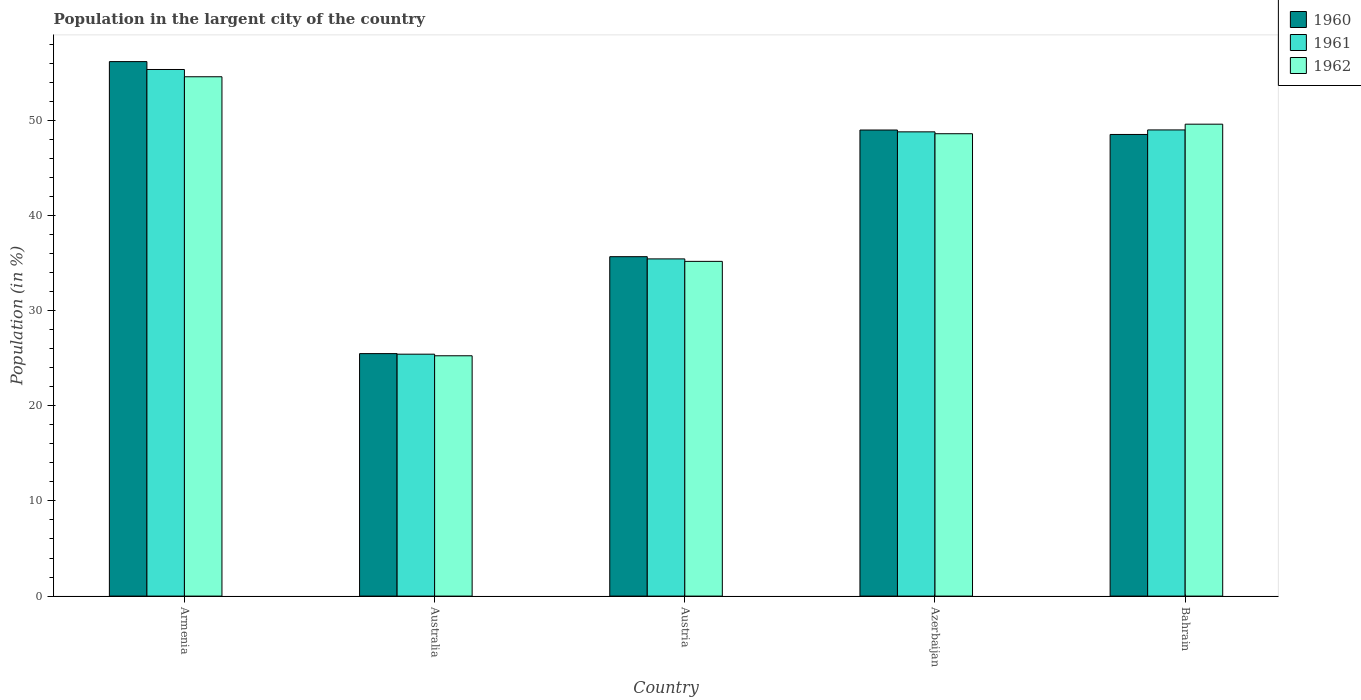How many groups of bars are there?
Provide a short and direct response. 5. Are the number of bars on each tick of the X-axis equal?
Offer a very short reply. Yes. What is the percentage of population in the largent city in 1960 in Armenia?
Ensure brevity in your answer.  56.16. Across all countries, what is the maximum percentage of population in the largent city in 1960?
Give a very brief answer. 56.16. Across all countries, what is the minimum percentage of population in the largent city in 1962?
Provide a short and direct response. 25.25. In which country was the percentage of population in the largent city in 1961 maximum?
Your answer should be compact. Armenia. What is the total percentage of population in the largent city in 1961 in the graph?
Provide a short and direct response. 213.95. What is the difference between the percentage of population in the largent city in 1961 in Armenia and that in Bahrain?
Provide a succinct answer. 6.35. What is the difference between the percentage of population in the largent city in 1961 in Austria and the percentage of population in the largent city in 1960 in Azerbaijan?
Provide a succinct answer. -13.54. What is the average percentage of population in the largent city in 1961 per country?
Offer a very short reply. 42.79. What is the difference between the percentage of population in the largent city of/in 1960 and percentage of population in the largent city of/in 1962 in Austria?
Ensure brevity in your answer.  0.49. In how many countries, is the percentage of population in the largent city in 1960 greater than 54 %?
Your answer should be very brief. 1. What is the ratio of the percentage of population in the largent city in 1960 in Armenia to that in Azerbaijan?
Provide a short and direct response. 1.15. Is the percentage of population in the largent city in 1962 in Australia less than that in Austria?
Provide a succinct answer. Yes. What is the difference between the highest and the second highest percentage of population in the largent city in 1962?
Make the answer very short. -1. What is the difference between the highest and the lowest percentage of population in the largent city in 1960?
Your response must be concise. 30.68. In how many countries, is the percentage of population in the largent city in 1962 greater than the average percentage of population in the largent city in 1962 taken over all countries?
Your response must be concise. 3. What does the 3rd bar from the left in Bahrain represents?
Make the answer very short. 1962. What does the 2nd bar from the right in Armenia represents?
Offer a very short reply. 1961. How many bars are there?
Provide a succinct answer. 15. Are all the bars in the graph horizontal?
Provide a short and direct response. No. Does the graph contain grids?
Offer a terse response. No. How many legend labels are there?
Make the answer very short. 3. How are the legend labels stacked?
Make the answer very short. Vertical. What is the title of the graph?
Keep it short and to the point. Population in the largent city of the country. Does "2002" appear as one of the legend labels in the graph?
Ensure brevity in your answer.  No. What is the label or title of the X-axis?
Offer a very short reply. Country. What is the Population (in %) in 1960 in Armenia?
Offer a terse response. 56.16. What is the Population (in %) of 1961 in Armenia?
Your answer should be very brief. 55.33. What is the Population (in %) of 1962 in Armenia?
Keep it short and to the point. 54.57. What is the Population (in %) in 1960 in Australia?
Your response must be concise. 25.48. What is the Population (in %) of 1961 in Australia?
Offer a terse response. 25.42. What is the Population (in %) in 1962 in Australia?
Your response must be concise. 25.25. What is the Population (in %) of 1960 in Austria?
Your response must be concise. 35.66. What is the Population (in %) in 1961 in Austria?
Keep it short and to the point. 35.43. What is the Population (in %) of 1962 in Austria?
Make the answer very short. 35.17. What is the Population (in %) of 1960 in Azerbaijan?
Ensure brevity in your answer.  48.97. What is the Population (in %) of 1961 in Azerbaijan?
Provide a succinct answer. 48.78. What is the Population (in %) of 1962 in Azerbaijan?
Your answer should be very brief. 48.58. What is the Population (in %) in 1960 in Bahrain?
Give a very brief answer. 48.51. What is the Population (in %) of 1961 in Bahrain?
Offer a terse response. 48.98. What is the Population (in %) in 1962 in Bahrain?
Provide a succinct answer. 49.59. Across all countries, what is the maximum Population (in %) of 1960?
Provide a succinct answer. 56.16. Across all countries, what is the maximum Population (in %) in 1961?
Give a very brief answer. 55.33. Across all countries, what is the maximum Population (in %) in 1962?
Make the answer very short. 54.57. Across all countries, what is the minimum Population (in %) of 1960?
Your answer should be very brief. 25.48. Across all countries, what is the minimum Population (in %) of 1961?
Offer a terse response. 25.42. Across all countries, what is the minimum Population (in %) of 1962?
Keep it short and to the point. 25.25. What is the total Population (in %) in 1960 in the graph?
Provide a succinct answer. 214.79. What is the total Population (in %) in 1961 in the graph?
Your answer should be compact. 213.95. What is the total Population (in %) in 1962 in the graph?
Make the answer very short. 213.16. What is the difference between the Population (in %) of 1960 in Armenia and that in Australia?
Your response must be concise. 30.68. What is the difference between the Population (in %) of 1961 in Armenia and that in Australia?
Ensure brevity in your answer.  29.91. What is the difference between the Population (in %) in 1962 in Armenia and that in Australia?
Offer a very short reply. 29.32. What is the difference between the Population (in %) in 1960 in Armenia and that in Austria?
Offer a terse response. 20.5. What is the difference between the Population (in %) in 1961 in Armenia and that in Austria?
Give a very brief answer. 19.9. What is the difference between the Population (in %) of 1962 in Armenia and that in Austria?
Your answer should be very brief. 19.4. What is the difference between the Population (in %) of 1960 in Armenia and that in Azerbaijan?
Your response must be concise. 7.19. What is the difference between the Population (in %) in 1961 in Armenia and that in Azerbaijan?
Give a very brief answer. 6.55. What is the difference between the Population (in %) in 1962 in Armenia and that in Azerbaijan?
Provide a short and direct response. 5.99. What is the difference between the Population (in %) in 1960 in Armenia and that in Bahrain?
Ensure brevity in your answer.  7.66. What is the difference between the Population (in %) in 1961 in Armenia and that in Bahrain?
Ensure brevity in your answer.  6.35. What is the difference between the Population (in %) of 1962 in Armenia and that in Bahrain?
Your answer should be very brief. 4.98. What is the difference between the Population (in %) of 1960 in Australia and that in Austria?
Provide a succinct answer. -10.19. What is the difference between the Population (in %) of 1961 in Australia and that in Austria?
Provide a succinct answer. -10.01. What is the difference between the Population (in %) of 1962 in Australia and that in Austria?
Your answer should be compact. -9.92. What is the difference between the Population (in %) of 1960 in Australia and that in Azerbaijan?
Your answer should be compact. -23.49. What is the difference between the Population (in %) in 1961 in Australia and that in Azerbaijan?
Provide a short and direct response. -23.36. What is the difference between the Population (in %) in 1962 in Australia and that in Azerbaijan?
Your response must be concise. -23.33. What is the difference between the Population (in %) in 1960 in Australia and that in Bahrain?
Provide a succinct answer. -23.03. What is the difference between the Population (in %) in 1961 in Australia and that in Bahrain?
Provide a short and direct response. -23.56. What is the difference between the Population (in %) of 1962 in Australia and that in Bahrain?
Provide a short and direct response. -24.33. What is the difference between the Population (in %) of 1960 in Austria and that in Azerbaijan?
Provide a short and direct response. -13.31. What is the difference between the Population (in %) of 1961 in Austria and that in Azerbaijan?
Your response must be concise. -13.35. What is the difference between the Population (in %) in 1962 in Austria and that in Azerbaijan?
Make the answer very short. -13.41. What is the difference between the Population (in %) of 1960 in Austria and that in Bahrain?
Ensure brevity in your answer.  -12.84. What is the difference between the Population (in %) in 1961 in Austria and that in Bahrain?
Provide a succinct answer. -13.55. What is the difference between the Population (in %) in 1962 in Austria and that in Bahrain?
Make the answer very short. -14.41. What is the difference between the Population (in %) of 1960 in Azerbaijan and that in Bahrain?
Provide a short and direct response. 0.47. What is the difference between the Population (in %) of 1961 in Azerbaijan and that in Bahrain?
Keep it short and to the point. -0.2. What is the difference between the Population (in %) of 1962 in Azerbaijan and that in Bahrain?
Provide a short and direct response. -1. What is the difference between the Population (in %) of 1960 in Armenia and the Population (in %) of 1961 in Australia?
Provide a short and direct response. 30.74. What is the difference between the Population (in %) in 1960 in Armenia and the Population (in %) in 1962 in Australia?
Give a very brief answer. 30.91. What is the difference between the Population (in %) in 1961 in Armenia and the Population (in %) in 1962 in Australia?
Ensure brevity in your answer.  30.08. What is the difference between the Population (in %) of 1960 in Armenia and the Population (in %) of 1961 in Austria?
Your answer should be very brief. 20.73. What is the difference between the Population (in %) of 1960 in Armenia and the Population (in %) of 1962 in Austria?
Your answer should be compact. 20.99. What is the difference between the Population (in %) in 1961 in Armenia and the Population (in %) in 1962 in Austria?
Your answer should be very brief. 20.16. What is the difference between the Population (in %) of 1960 in Armenia and the Population (in %) of 1961 in Azerbaijan?
Your response must be concise. 7.38. What is the difference between the Population (in %) of 1960 in Armenia and the Population (in %) of 1962 in Azerbaijan?
Keep it short and to the point. 7.58. What is the difference between the Population (in %) of 1961 in Armenia and the Population (in %) of 1962 in Azerbaijan?
Make the answer very short. 6.75. What is the difference between the Population (in %) in 1960 in Armenia and the Population (in %) in 1961 in Bahrain?
Ensure brevity in your answer.  7.18. What is the difference between the Population (in %) in 1960 in Armenia and the Population (in %) in 1962 in Bahrain?
Offer a very short reply. 6.58. What is the difference between the Population (in %) in 1961 in Armenia and the Population (in %) in 1962 in Bahrain?
Give a very brief answer. 5.75. What is the difference between the Population (in %) in 1960 in Australia and the Population (in %) in 1961 in Austria?
Offer a terse response. -9.95. What is the difference between the Population (in %) in 1960 in Australia and the Population (in %) in 1962 in Austria?
Provide a succinct answer. -9.69. What is the difference between the Population (in %) of 1961 in Australia and the Population (in %) of 1962 in Austria?
Give a very brief answer. -9.75. What is the difference between the Population (in %) in 1960 in Australia and the Population (in %) in 1961 in Azerbaijan?
Offer a terse response. -23.3. What is the difference between the Population (in %) of 1960 in Australia and the Population (in %) of 1962 in Azerbaijan?
Your response must be concise. -23.11. What is the difference between the Population (in %) in 1961 in Australia and the Population (in %) in 1962 in Azerbaijan?
Give a very brief answer. -23.16. What is the difference between the Population (in %) in 1960 in Australia and the Population (in %) in 1961 in Bahrain?
Provide a short and direct response. -23.5. What is the difference between the Population (in %) of 1960 in Australia and the Population (in %) of 1962 in Bahrain?
Keep it short and to the point. -24.11. What is the difference between the Population (in %) of 1961 in Australia and the Population (in %) of 1962 in Bahrain?
Make the answer very short. -24.17. What is the difference between the Population (in %) in 1960 in Austria and the Population (in %) in 1961 in Azerbaijan?
Your response must be concise. -13.12. What is the difference between the Population (in %) in 1960 in Austria and the Population (in %) in 1962 in Azerbaijan?
Make the answer very short. -12.92. What is the difference between the Population (in %) of 1961 in Austria and the Population (in %) of 1962 in Azerbaijan?
Provide a short and direct response. -13.15. What is the difference between the Population (in %) of 1960 in Austria and the Population (in %) of 1961 in Bahrain?
Offer a very short reply. -13.32. What is the difference between the Population (in %) in 1960 in Austria and the Population (in %) in 1962 in Bahrain?
Offer a very short reply. -13.92. What is the difference between the Population (in %) of 1961 in Austria and the Population (in %) of 1962 in Bahrain?
Keep it short and to the point. -14.15. What is the difference between the Population (in %) of 1960 in Azerbaijan and the Population (in %) of 1961 in Bahrain?
Provide a short and direct response. -0.01. What is the difference between the Population (in %) of 1960 in Azerbaijan and the Population (in %) of 1962 in Bahrain?
Keep it short and to the point. -0.61. What is the difference between the Population (in %) in 1961 in Azerbaijan and the Population (in %) in 1962 in Bahrain?
Keep it short and to the point. -0.81. What is the average Population (in %) in 1960 per country?
Your answer should be compact. 42.96. What is the average Population (in %) of 1961 per country?
Offer a very short reply. 42.79. What is the average Population (in %) in 1962 per country?
Keep it short and to the point. 42.63. What is the difference between the Population (in %) in 1960 and Population (in %) in 1961 in Armenia?
Your answer should be compact. 0.83. What is the difference between the Population (in %) in 1960 and Population (in %) in 1962 in Armenia?
Keep it short and to the point. 1.59. What is the difference between the Population (in %) of 1961 and Population (in %) of 1962 in Armenia?
Make the answer very short. 0.76. What is the difference between the Population (in %) of 1960 and Population (in %) of 1961 in Australia?
Make the answer very short. 0.06. What is the difference between the Population (in %) in 1960 and Population (in %) in 1962 in Australia?
Offer a terse response. 0.23. What is the difference between the Population (in %) of 1961 and Population (in %) of 1962 in Australia?
Your answer should be compact. 0.17. What is the difference between the Population (in %) in 1960 and Population (in %) in 1961 in Austria?
Your response must be concise. 0.23. What is the difference between the Population (in %) of 1960 and Population (in %) of 1962 in Austria?
Give a very brief answer. 0.49. What is the difference between the Population (in %) in 1961 and Population (in %) in 1962 in Austria?
Ensure brevity in your answer.  0.26. What is the difference between the Population (in %) in 1960 and Population (in %) in 1961 in Azerbaijan?
Provide a short and direct response. 0.19. What is the difference between the Population (in %) in 1960 and Population (in %) in 1962 in Azerbaijan?
Offer a very short reply. 0.39. What is the difference between the Population (in %) in 1961 and Population (in %) in 1962 in Azerbaijan?
Offer a very short reply. 0.2. What is the difference between the Population (in %) in 1960 and Population (in %) in 1961 in Bahrain?
Make the answer very short. -0.48. What is the difference between the Population (in %) in 1960 and Population (in %) in 1962 in Bahrain?
Provide a succinct answer. -1.08. What is the difference between the Population (in %) in 1961 and Population (in %) in 1962 in Bahrain?
Provide a succinct answer. -0.6. What is the ratio of the Population (in %) in 1960 in Armenia to that in Australia?
Offer a terse response. 2.2. What is the ratio of the Population (in %) in 1961 in Armenia to that in Australia?
Make the answer very short. 2.18. What is the ratio of the Population (in %) in 1962 in Armenia to that in Australia?
Keep it short and to the point. 2.16. What is the ratio of the Population (in %) in 1960 in Armenia to that in Austria?
Your answer should be very brief. 1.57. What is the ratio of the Population (in %) in 1961 in Armenia to that in Austria?
Your answer should be very brief. 1.56. What is the ratio of the Population (in %) of 1962 in Armenia to that in Austria?
Offer a terse response. 1.55. What is the ratio of the Population (in %) of 1960 in Armenia to that in Azerbaijan?
Provide a short and direct response. 1.15. What is the ratio of the Population (in %) in 1961 in Armenia to that in Azerbaijan?
Your answer should be very brief. 1.13. What is the ratio of the Population (in %) of 1962 in Armenia to that in Azerbaijan?
Provide a short and direct response. 1.12. What is the ratio of the Population (in %) in 1960 in Armenia to that in Bahrain?
Make the answer very short. 1.16. What is the ratio of the Population (in %) of 1961 in Armenia to that in Bahrain?
Your answer should be very brief. 1.13. What is the ratio of the Population (in %) in 1962 in Armenia to that in Bahrain?
Give a very brief answer. 1.1. What is the ratio of the Population (in %) in 1960 in Australia to that in Austria?
Give a very brief answer. 0.71. What is the ratio of the Population (in %) in 1961 in Australia to that in Austria?
Offer a terse response. 0.72. What is the ratio of the Population (in %) of 1962 in Australia to that in Austria?
Your answer should be very brief. 0.72. What is the ratio of the Population (in %) in 1960 in Australia to that in Azerbaijan?
Provide a succinct answer. 0.52. What is the ratio of the Population (in %) in 1961 in Australia to that in Azerbaijan?
Keep it short and to the point. 0.52. What is the ratio of the Population (in %) in 1962 in Australia to that in Azerbaijan?
Provide a short and direct response. 0.52. What is the ratio of the Population (in %) of 1960 in Australia to that in Bahrain?
Offer a terse response. 0.53. What is the ratio of the Population (in %) of 1961 in Australia to that in Bahrain?
Give a very brief answer. 0.52. What is the ratio of the Population (in %) in 1962 in Australia to that in Bahrain?
Offer a terse response. 0.51. What is the ratio of the Population (in %) in 1960 in Austria to that in Azerbaijan?
Provide a short and direct response. 0.73. What is the ratio of the Population (in %) of 1961 in Austria to that in Azerbaijan?
Provide a short and direct response. 0.73. What is the ratio of the Population (in %) in 1962 in Austria to that in Azerbaijan?
Your response must be concise. 0.72. What is the ratio of the Population (in %) in 1960 in Austria to that in Bahrain?
Offer a very short reply. 0.74. What is the ratio of the Population (in %) in 1961 in Austria to that in Bahrain?
Offer a very short reply. 0.72. What is the ratio of the Population (in %) of 1962 in Austria to that in Bahrain?
Give a very brief answer. 0.71. What is the ratio of the Population (in %) in 1960 in Azerbaijan to that in Bahrain?
Your response must be concise. 1.01. What is the ratio of the Population (in %) in 1961 in Azerbaijan to that in Bahrain?
Offer a terse response. 1. What is the ratio of the Population (in %) of 1962 in Azerbaijan to that in Bahrain?
Your answer should be very brief. 0.98. What is the difference between the highest and the second highest Population (in %) of 1960?
Provide a succinct answer. 7.19. What is the difference between the highest and the second highest Population (in %) of 1961?
Provide a succinct answer. 6.35. What is the difference between the highest and the second highest Population (in %) of 1962?
Give a very brief answer. 4.98. What is the difference between the highest and the lowest Population (in %) of 1960?
Provide a short and direct response. 30.68. What is the difference between the highest and the lowest Population (in %) of 1961?
Provide a succinct answer. 29.91. What is the difference between the highest and the lowest Population (in %) in 1962?
Provide a succinct answer. 29.32. 